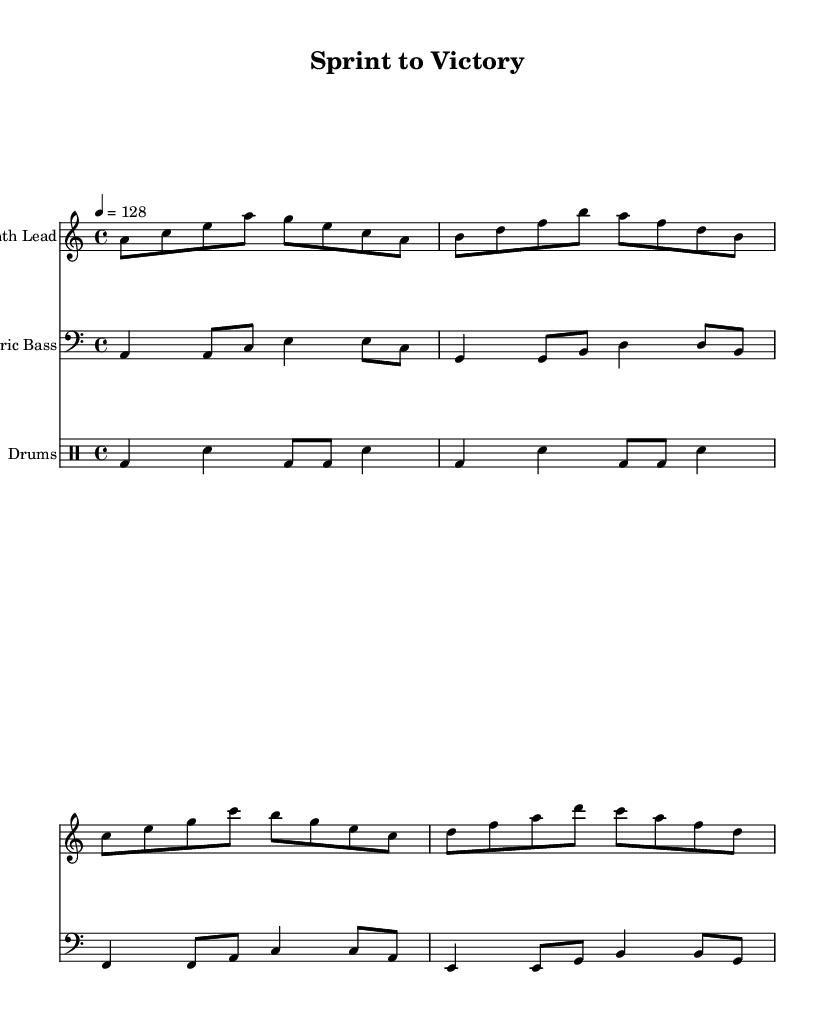What is the key signature of this music? The key signature is A minor, which is denoted by one sharp (G#) that is implied but not explicitly written.
Answer: A minor What is the time signature of this music? The time signature shown at the beginning is 4/4, which indicates four beats per measure and a quarter note receives one beat.
Answer: 4/4 What is the tempo marking for the piece? The tempo marking is indicated as 4 = 128, meaning the quarter note should be played at a speed of 128 beats per minute.
Answer: 128 Which instrument part features a synthesizer lead? The instrument part labeled "Synth Lead" is designated for creating melodies using electronic sounds, as seen in the staff notation.
Answer: Synth Lead How many measures are in the electric bass part? The electric bass part consists of four measures, each containing a combination of quarter and eighth notes.
Answer: 4 What type of rhythm is primarily used in the drums part? The drums use a combination of bass drum and snare hits, which can be classified as a standard backbeat rhythm characteristic of R&B.
Answer: Backbeat What genre does this piece blend with electronic elements? The piece is a high-energy R&B fusion, incorporating electronic elements to enhance the intensity suitable for training sessions.
Answer: R&B fusion 